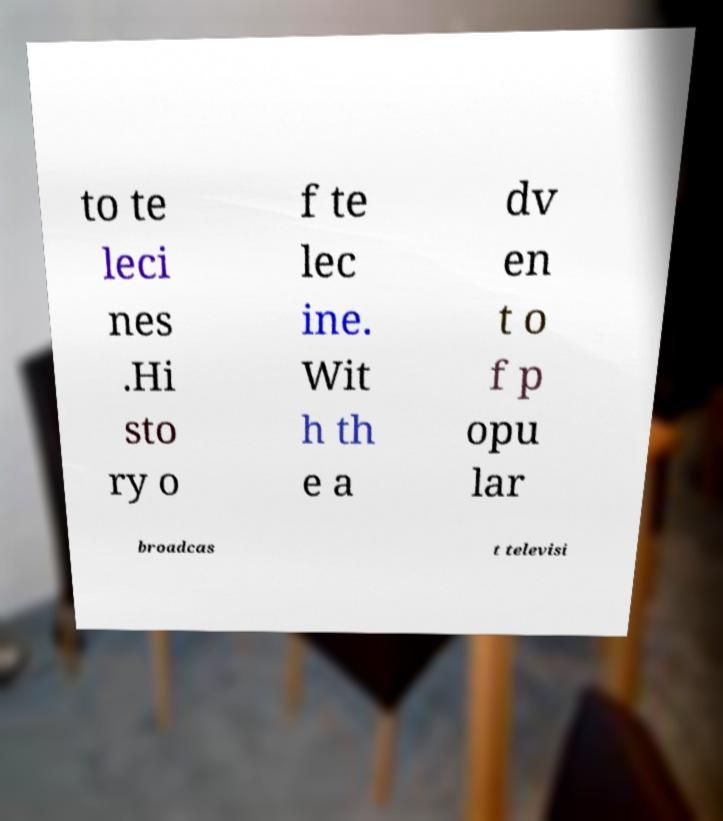Can you accurately transcribe the text from the provided image for me? to te leci nes .Hi sto ry o f te lec ine. Wit h th e a dv en t o f p opu lar broadcas t televisi 